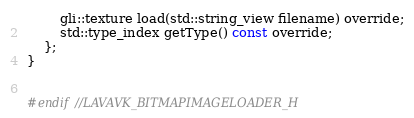Convert code to text. <code><loc_0><loc_0><loc_500><loc_500><_C_>        gli::texture load(std::string_view filename) override;
        std::type_index getType() const override;
    };
}


#endif //LAVAVK_BITMAPIMAGELOADER_H
</code> 